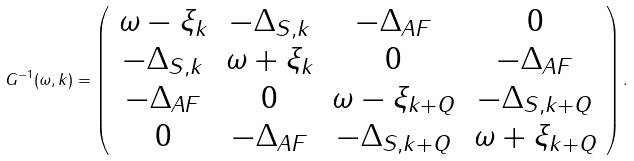Convert formula to latex. <formula><loc_0><loc_0><loc_500><loc_500>G ^ { - 1 } ( \omega , { k } ) = \left ( \begin{array} { c c c c } \omega - \xi _ { k } & - \Delta _ { S , k } & - \Delta _ { A F } & 0 \\ - \Delta _ { S , k } & \omega + \xi _ { k } & 0 & - \Delta _ { A F } \\ - \Delta _ { A F } & 0 & \omega - \xi _ { k + Q } & - \Delta _ { S , { k + Q } } \\ 0 & - \Delta _ { A F } & - \Delta _ { S , k + Q } & \omega + \xi _ { k + Q } \end{array} \right ) .</formula> 